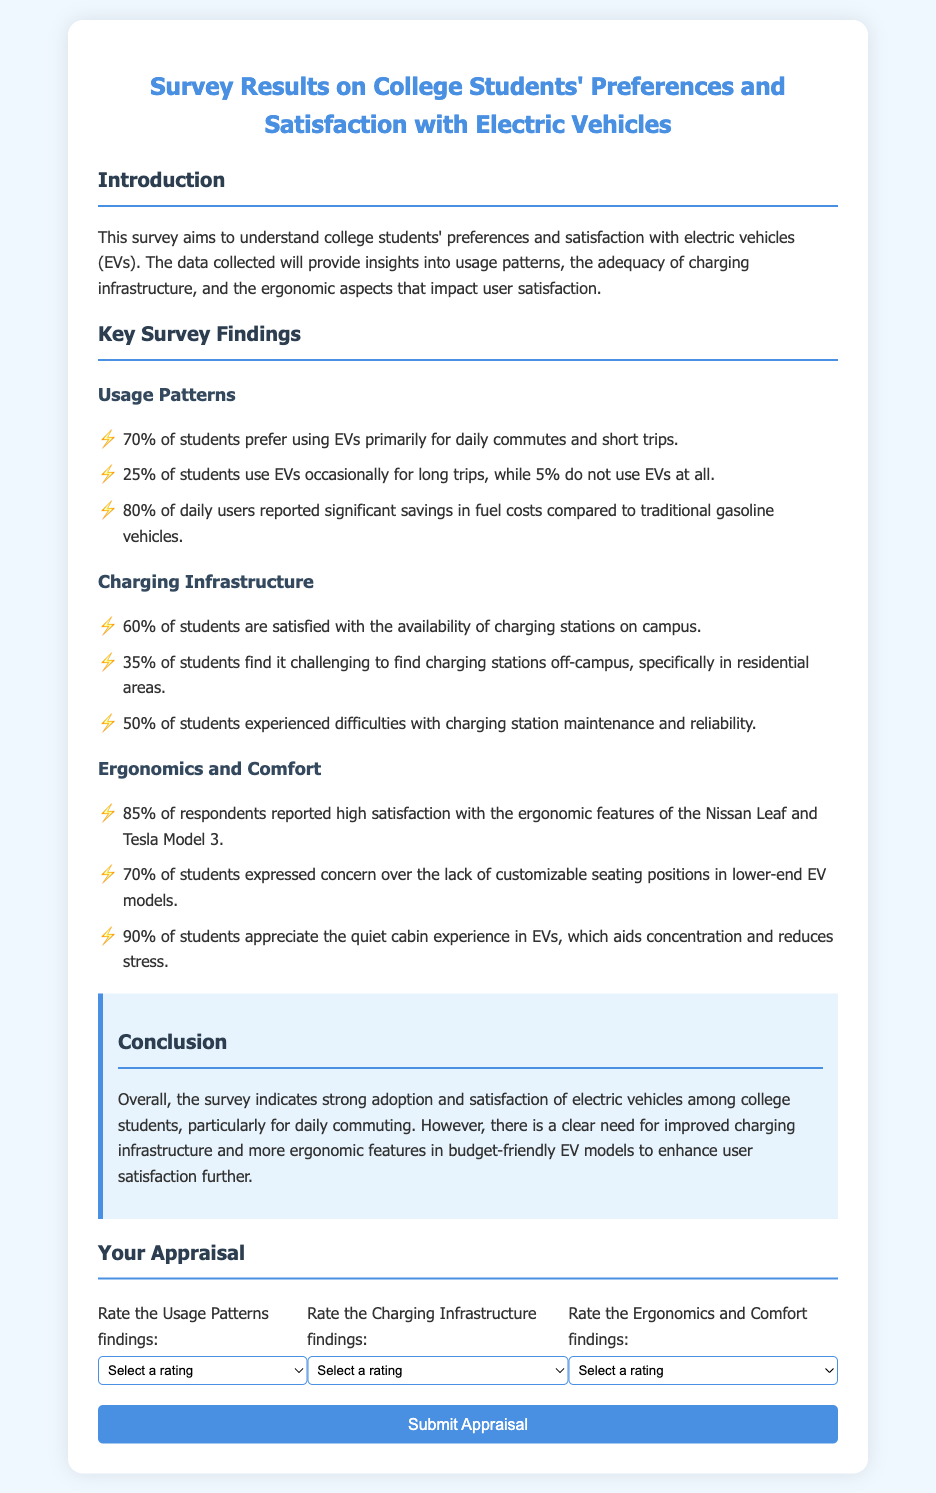What percentage of students prefer using EVs for daily commutes? The document states that 70% of students prefer using EVs primarily for daily commutes and short trips.
Answer: 70% What is the satisfaction level regarding the availability of charging stations on campus? According to the document, 60% of students are satisfied with the availability of charging stations on campus.
Answer: 60% How many students expressed concern about customizable seating positions in lower-end EV models? The document mentions that 70% of students expressed concern over the lack of customizable seating positions in lower-end EV models.
Answer: 70% What is the percentage of daily users reporting savings in fuel costs compared to traditional vehicles? The document reports that 80% of daily users noted significant savings in fuel costs compared to traditional gasoline vehicles.
Answer: 80% How many students found it challenging to locate charging stations off-campus? The document indicates that 35% of students find it challenging to find charging stations off-campus.
Answer: 35% What is the main concern pointed out by students regarding charging station maintenance? The document states that 50% of students experienced difficulties with charging station maintenance and reliability.
Answer: Maintenance What ergonomic feature has high satisfaction ratings among students for specific EV models? According to the document, 85% of respondents reported high satisfaction with the ergonomic features of the Nissan Leaf and Tesla Model 3.
Answer: Nissan Leaf and Tesla Model 3 What conclusion is drawn regarding the adoption of electric vehicles among college students? The conclusion highlights strong adoption and satisfaction with electric vehicles among college students, particularly for daily commuting.
Answer: Strong adoption What specific area needs improvement according to the survey results? The document emphasizes the need for improved charging infrastructure and more ergonomic features in budget-friendly EV models.
Answer: Charging infrastructure 